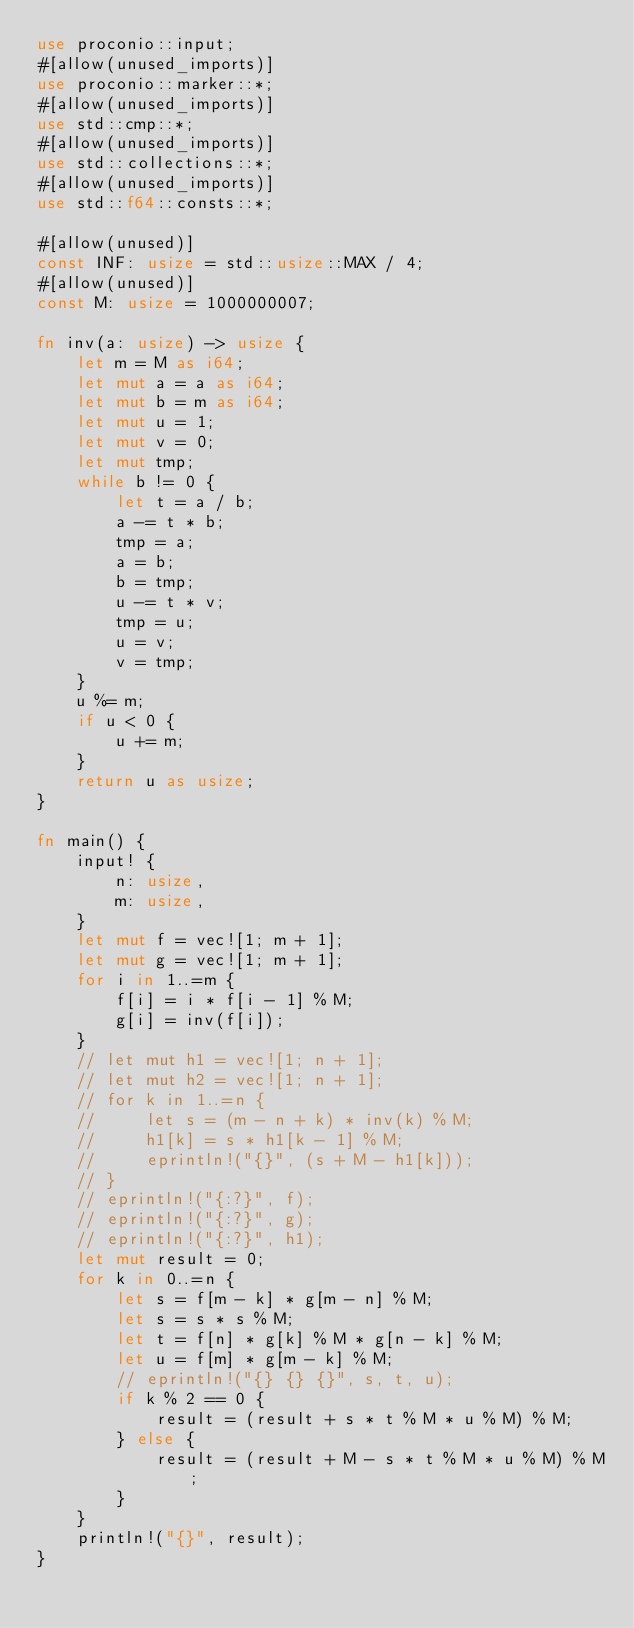<code> <loc_0><loc_0><loc_500><loc_500><_Rust_>use proconio::input;
#[allow(unused_imports)]
use proconio::marker::*;
#[allow(unused_imports)]
use std::cmp::*;
#[allow(unused_imports)]
use std::collections::*;
#[allow(unused_imports)]
use std::f64::consts::*;

#[allow(unused)]
const INF: usize = std::usize::MAX / 4;
#[allow(unused)]
const M: usize = 1000000007;

fn inv(a: usize) -> usize {
    let m = M as i64;
    let mut a = a as i64;
    let mut b = m as i64;
    let mut u = 1;
    let mut v = 0;
    let mut tmp;
    while b != 0 {
        let t = a / b;
        a -= t * b;
        tmp = a;
        a = b;
        b = tmp;
        u -= t * v;
        tmp = u;
        u = v;
        v = tmp;
    }
    u %= m;
    if u < 0 {
        u += m;
    }
    return u as usize;
}

fn main() {
    input! {
        n: usize,
        m: usize,
    }
    let mut f = vec![1; m + 1];
    let mut g = vec![1; m + 1];
    for i in 1..=m {
        f[i] = i * f[i - 1] % M;
        g[i] = inv(f[i]);
    }
    // let mut h1 = vec![1; n + 1];
    // let mut h2 = vec![1; n + 1];
    // for k in 1..=n {
    //     let s = (m - n + k) * inv(k) % M;
    //     h1[k] = s * h1[k - 1] % M;
    //     eprintln!("{}", (s + M - h1[k]));
    // }
    // eprintln!("{:?}", f);
    // eprintln!("{:?}", g);
    // eprintln!("{:?}", h1);
    let mut result = 0;
    for k in 0..=n {
        let s = f[m - k] * g[m - n] % M;
        let s = s * s % M;
        let t = f[n] * g[k] % M * g[n - k] % M;
        let u = f[m] * g[m - k] % M;
        // eprintln!("{} {} {}", s, t, u);
        if k % 2 == 0 {
            result = (result + s * t % M * u % M) % M;
        } else {
            result = (result + M - s * t % M * u % M) % M;
        }
    }
    println!("{}", result);
}
</code> 